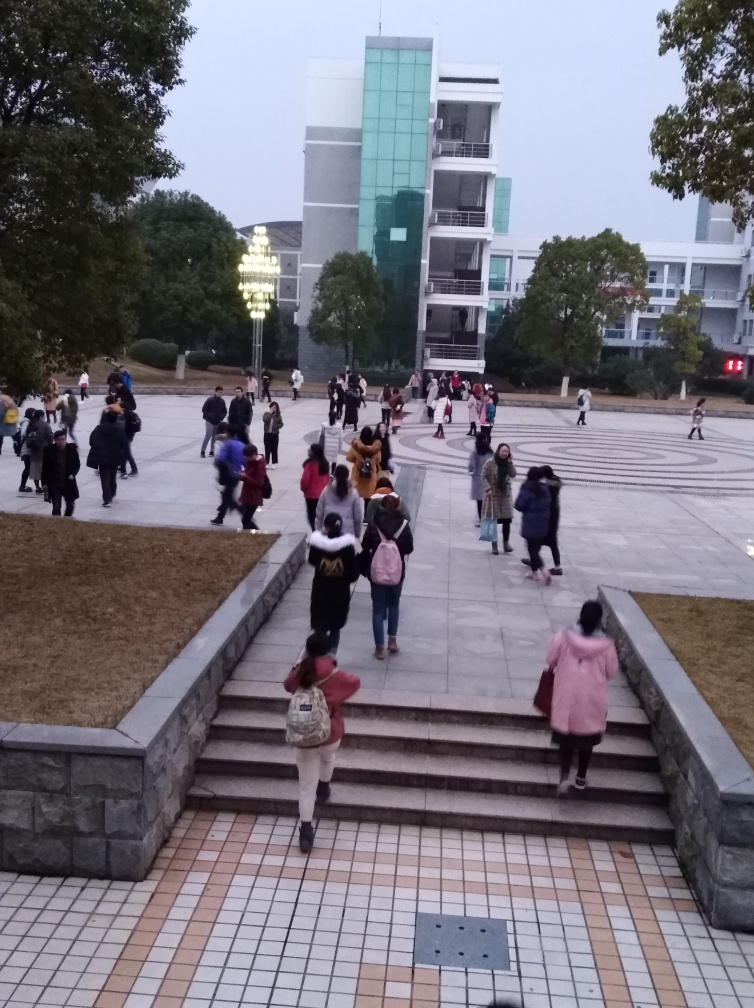Can you describe the architecture visible in the photo? The photo showcases a modern building with a distinctive glass facade and several floors. The overall design is minimalist, featuring clean lines and geometric shapes, which is typical of contemporary architectural styles. 